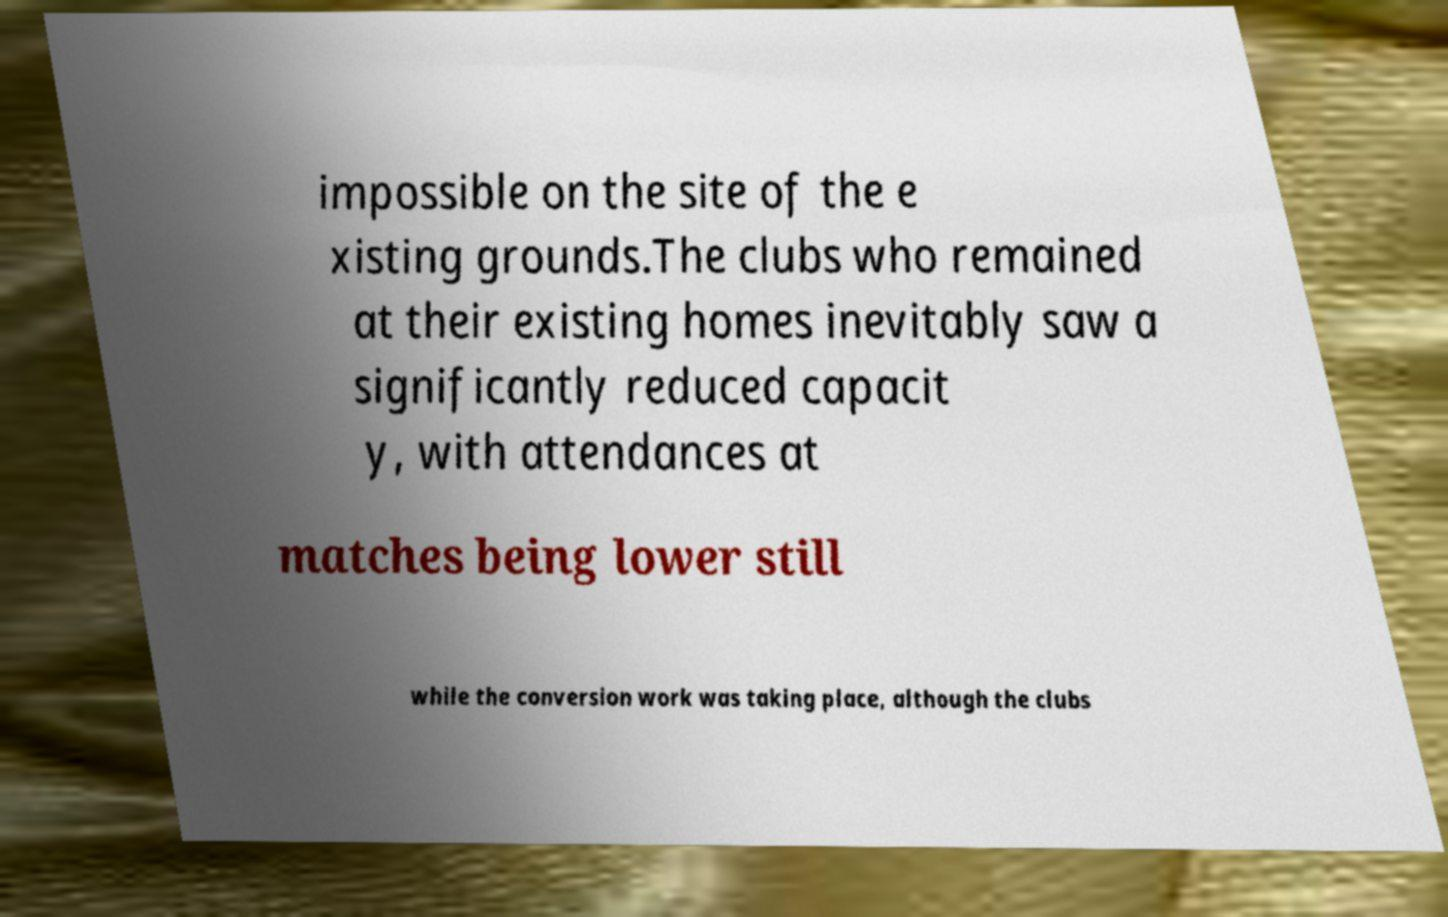What messages or text are displayed in this image? I need them in a readable, typed format. impossible on the site of the e xisting grounds.The clubs who remained at their existing homes inevitably saw a significantly reduced capacit y, with attendances at matches being lower still while the conversion work was taking place, although the clubs 